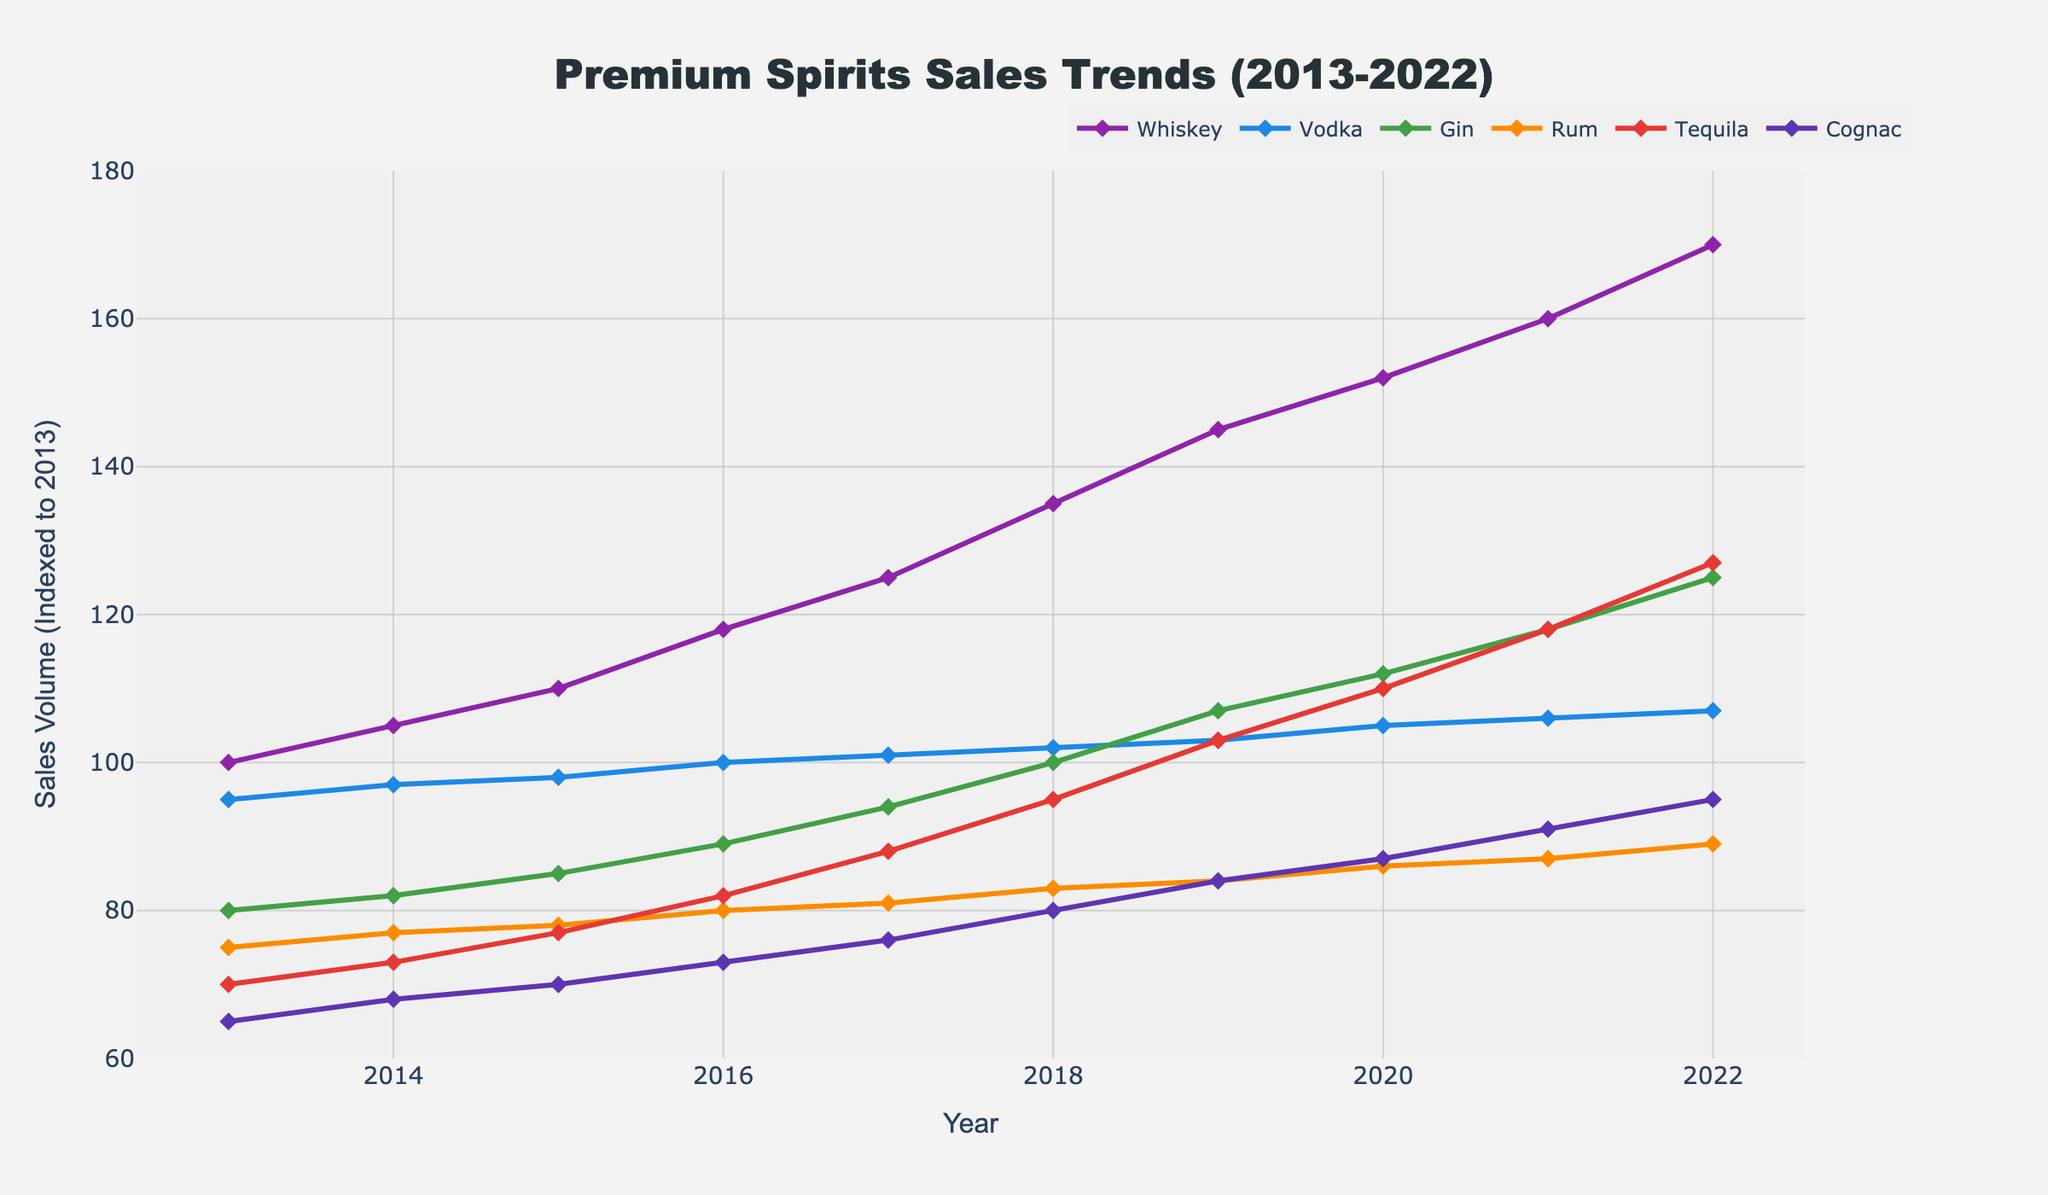What has been the overall trend for Whiskey sales over the past decade? To find the overall trend for Whiskey sales, we examine the Whiskey line from 2013 to 2022. The graph shows a consistent upward trend without any significant dips, indicating that Whiskey sales have increased steadily over the past decade.
Answer: Upward Which spirit had the highest sales in 2022? To determine the spirit with the highest sales in 2022, we look at the endpoints of each line corresponding to the year 2022. Whiskey had the highest endpoint, indicating the highest sales.
Answer: Whiskey How did the sales of Gin evolve compared to Vodka from 2013 to 2022? We compare the lines for Gin and Vodka over the decade. Initially, Vodka sales were higher than Gin, but by the end, Gin sales have surpassed Vodka, showing a steeper rise in Gin sales compared to Vodka.
Answer: Gin surpassed Vodka What is the difference in sales volume between Tequila and Rum in 2022? To find the difference, we look at the values for Tequila and Rum in 2022. Tequila sales are at 127, and Rum sales are at 89. Subtracting these gives us a difference of 127 - 89.
Answer: 38 Which spirit has shown the most stable sales trend over the decade? Examining the graph, we can identify the spirit with the least fluctuation in its sales volume over the decade. Vodka has a relatively stable and gradual increase compared to others.
Answer: Vodka What is the average sales volume for Cognac from 2013 to 2022? To find the average, we sum up the sales volumes of Cognac for each year from 2013 to 2022 and then divide by the number of years:
(65 + 68 + 70 + 73 + 76 + 80 + 84 + 87 + 91 + 95) / 10 = 78.9.
Answer: 78.9 In which year did Tequila sales first surpass 100? We need to look at the Tequila line and find the first year it crosses the 100 mark. As per the graph, this happened in 2019.
Answer: 2019 Between 2015 and 2018, which spirit had the highest increase in sales volume? We compare the increase in sales from 2015 to 2018 for each spirit. Whiskey increased from 110 to 135 (+25), Vodka from 98 to 102 (+4), Gin from 85 to 100 (+15), Rum from 78 to 83 (+5), Tequila from 77 to 95 (+18), and Cognac from 70 to 80 (+10). Whiskey had the highest increase.
Answer: Whiskey By how much did Rum sales increase from 2013 to 2022? To find the increase, we subtract Rum sales in 2013 from the sales in 2022. The values are 89 (2022) and 75 (2013), so 89 - 75 = 14.
Answer: 14 Comparing the year 2020 to 2021, which spirit had the largest growth in sales? We look at the difference in sales from 2020 to 2021 for each spirit. Whiskey: 160 - 152 = 8, Vodka: 106 - 105 = 1, Gin: 118 - 112 = 6, Rum: 87 - 86 = 1, Tequila: 118 - 110 = 8, Cognac: 91 - 87 = 4. Both Whiskey and Tequila had the largest growth (+8).
Answer: Whiskey and Tequila 